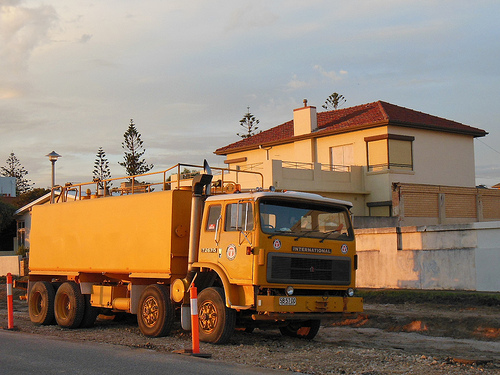Please provide a description for the region specified [0.01, 0.67, 0.42, 0.84]. This section highlights several orange safety cones, neatly placed within a gravel area, likely used to signal caution or to demarcate a specific zone. 